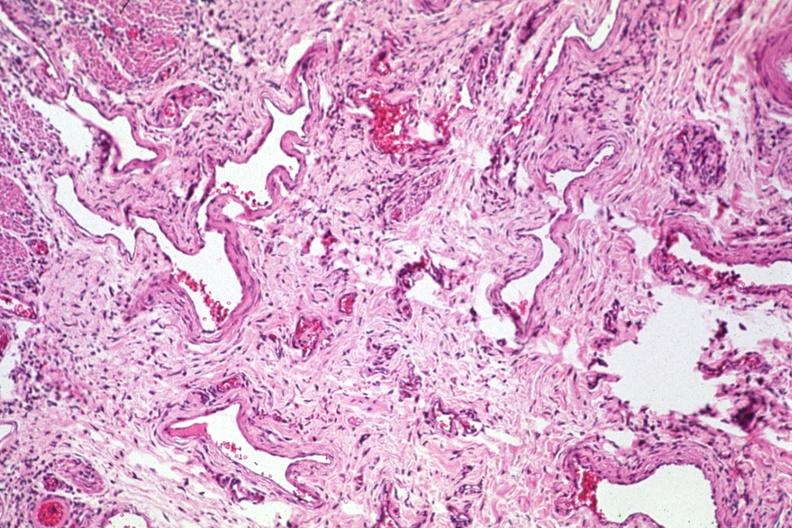what is present?
Answer the question using a single word or phrase. Gastrointestinal 